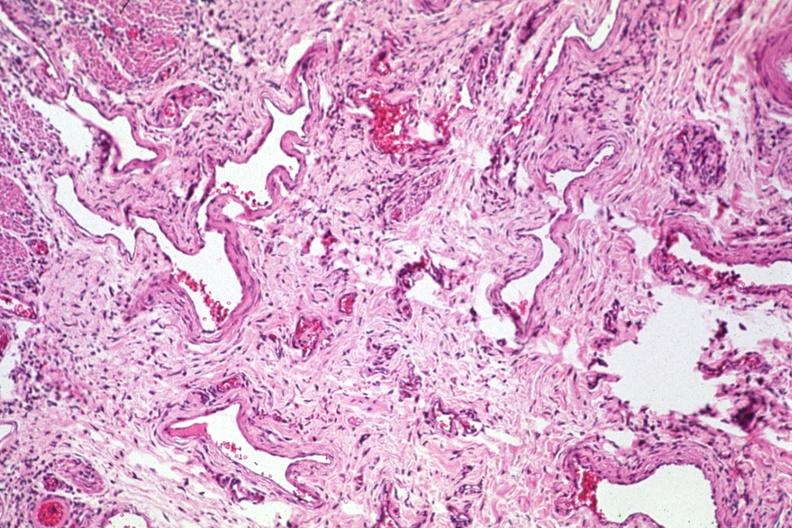what is present?
Answer the question using a single word or phrase. Gastrointestinal 